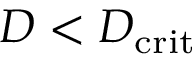Convert formula to latex. <formula><loc_0><loc_0><loc_500><loc_500>D < D _ { c r i t }</formula> 